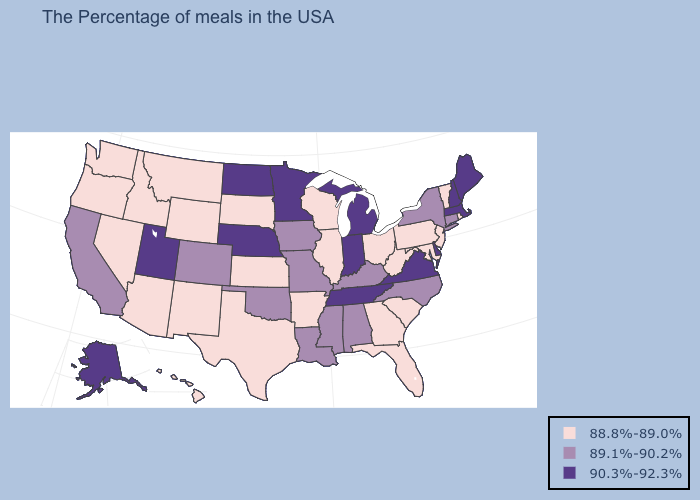Does Hawaii have the highest value in the USA?
Be succinct. No. Which states have the lowest value in the USA?
Be succinct. Rhode Island, Vermont, New Jersey, Maryland, Pennsylvania, South Carolina, West Virginia, Ohio, Florida, Georgia, Wisconsin, Illinois, Arkansas, Kansas, Texas, South Dakota, Wyoming, New Mexico, Montana, Arizona, Idaho, Nevada, Washington, Oregon, Hawaii. Name the states that have a value in the range 88.8%-89.0%?
Give a very brief answer. Rhode Island, Vermont, New Jersey, Maryland, Pennsylvania, South Carolina, West Virginia, Ohio, Florida, Georgia, Wisconsin, Illinois, Arkansas, Kansas, Texas, South Dakota, Wyoming, New Mexico, Montana, Arizona, Idaho, Nevada, Washington, Oregon, Hawaii. Name the states that have a value in the range 90.3%-92.3%?
Short answer required. Maine, Massachusetts, New Hampshire, Delaware, Virginia, Michigan, Indiana, Tennessee, Minnesota, Nebraska, North Dakota, Utah, Alaska. What is the lowest value in the South?
Answer briefly. 88.8%-89.0%. What is the lowest value in states that border South Carolina?
Give a very brief answer. 88.8%-89.0%. Name the states that have a value in the range 89.1%-90.2%?
Keep it brief. Connecticut, New York, North Carolina, Kentucky, Alabama, Mississippi, Louisiana, Missouri, Iowa, Oklahoma, Colorado, California. What is the highest value in the USA?
Short answer required. 90.3%-92.3%. Name the states that have a value in the range 89.1%-90.2%?
Keep it brief. Connecticut, New York, North Carolina, Kentucky, Alabama, Mississippi, Louisiana, Missouri, Iowa, Oklahoma, Colorado, California. Does the map have missing data?
Keep it brief. No. Does North Carolina have the highest value in the South?
Concise answer only. No. What is the highest value in the West ?
Be succinct. 90.3%-92.3%. What is the value of Texas?
Answer briefly. 88.8%-89.0%. What is the highest value in states that border Indiana?
Give a very brief answer. 90.3%-92.3%. What is the highest value in states that border Minnesota?
Keep it brief. 90.3%-92.3%. 